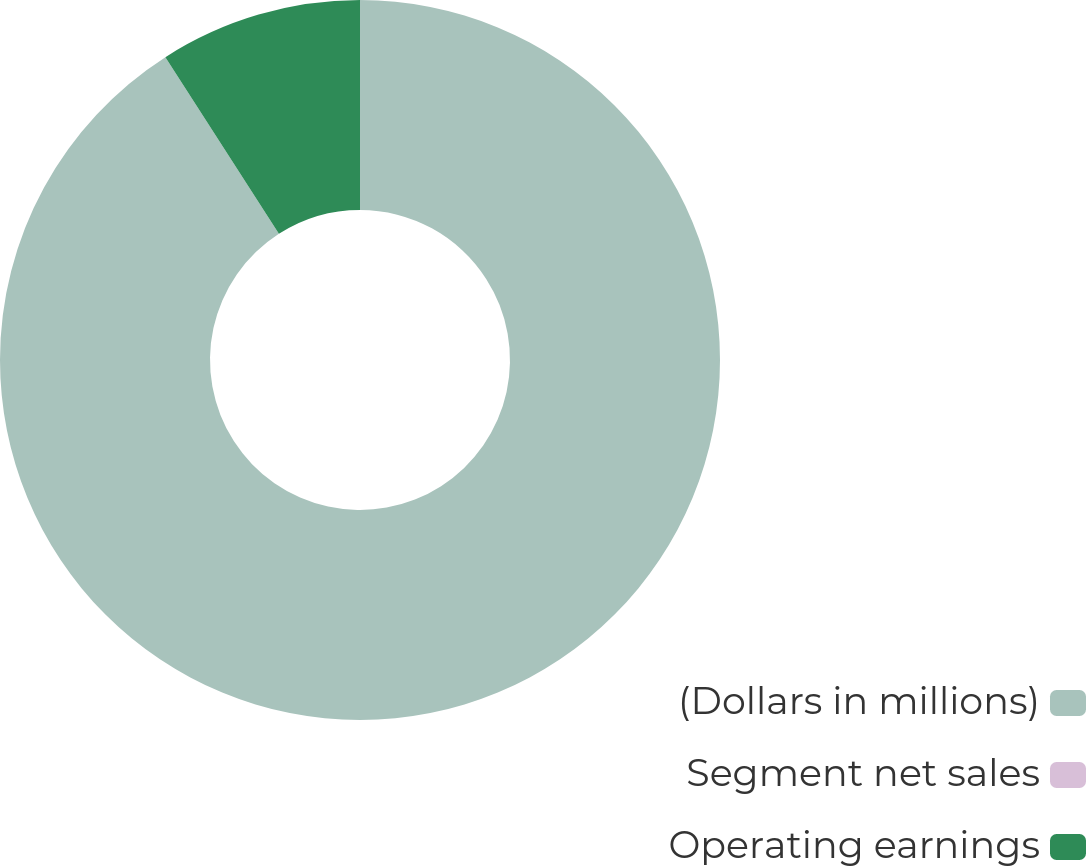<chart> <loc_0><loc_0><loc_500><loc_500><pie_chart><fcel>(Dollars in millions)<fcel>Segment net sales<fcel>Operating earnings<nl><fcel>90.91%<fcel>0.0%<fcel>9.09%<nl></chart> 